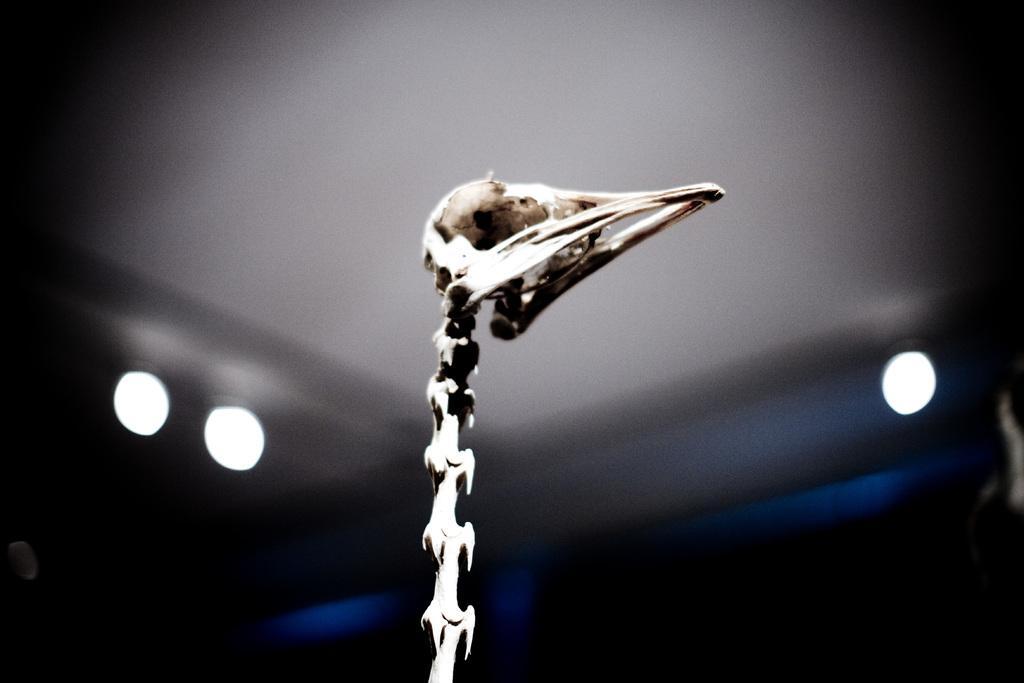Describe this image in one or two sentences. In the center of image, we can see a skull and in the background, there are lights and there is a wall. 